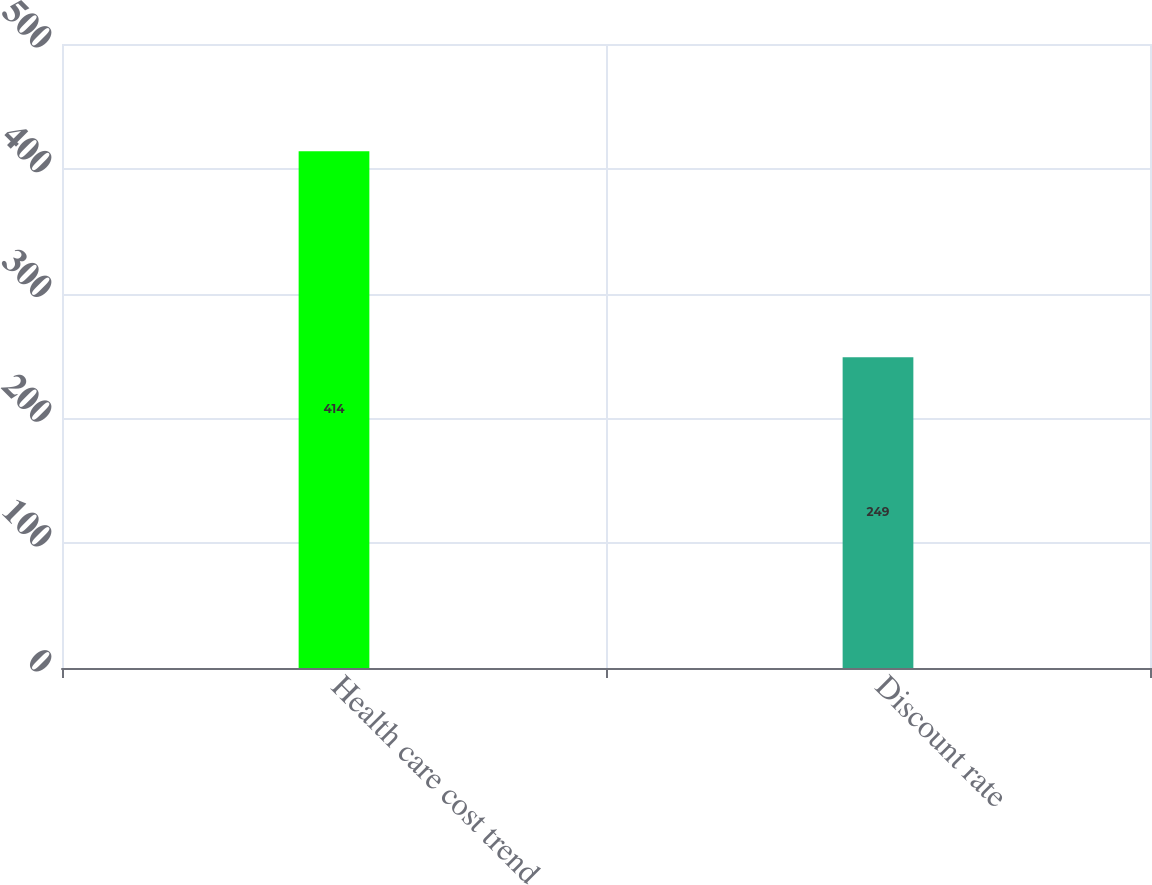Convert chart. <chart><loc_0><loc_0><loc_500><loc_500><bar_chart><fcel>Health care cost trend<fcel>Discount rate<nl><fcel>414<fcel>249<nl></chart> 